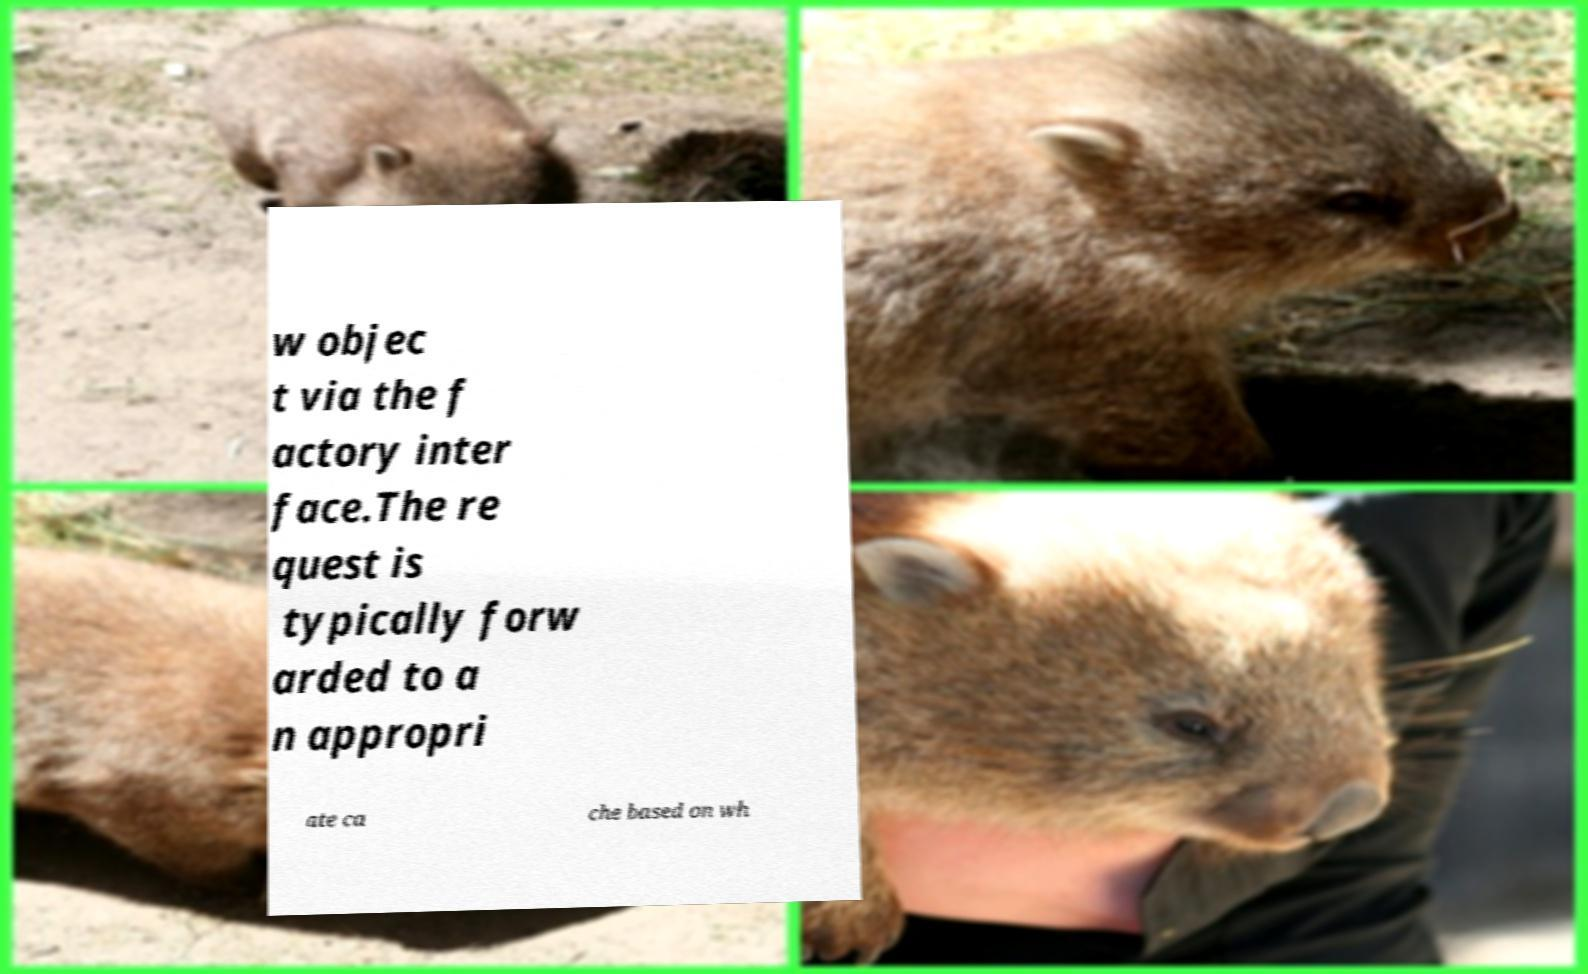Could you extract and type out the text from this image? w objec t via the f actory inter face.The re quest is typically forw arded to a n appropri ate ca che based on wh 